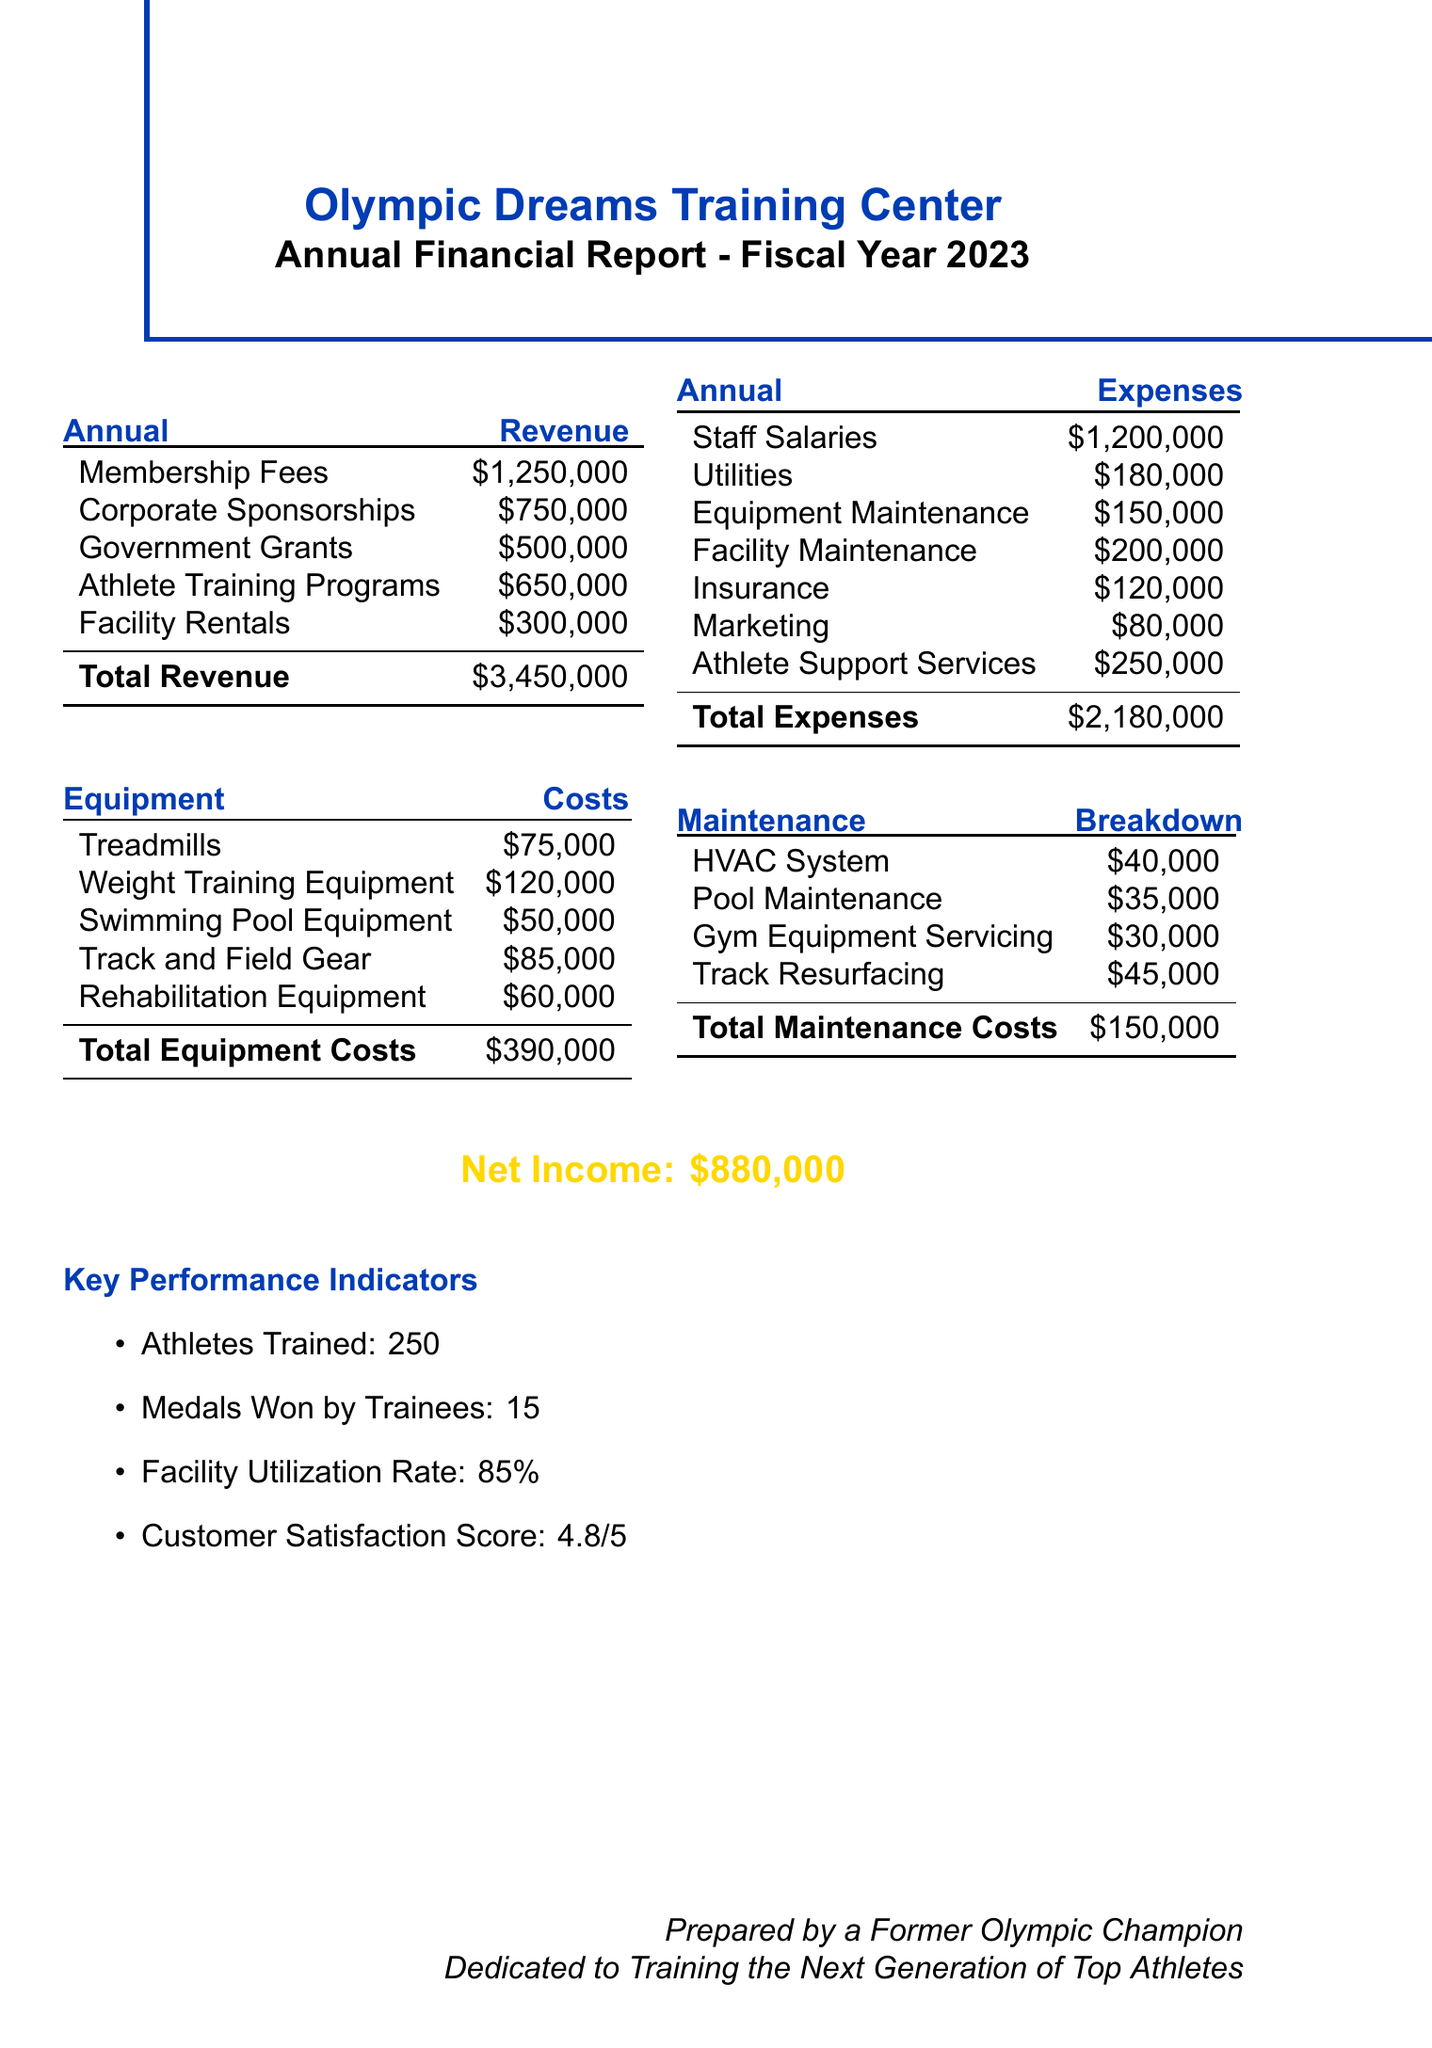what is the total revenue? The total revenue is the sum of all revenue sources in the document: membership fees, corporate sponsorships, government grants, athlete training programs, and facility rentals, which equals $3,450,000.
Answer: $3,450,000 what is the total expenses? The total expenses are the sum of all expenses listed, including staff salaries, utilities, equipment maintenance, facility maintenance, insurance, marketing, and athlete support services, totaling $2,180,000.
Answer: $2,180,000 how much was spent on equipment maintenance? The document specifies the cost of equipment maintenance as a distinct expense, which is $150,000.
Answer: $150,000 what is the net income for the fiscal year 2023? The net income is calculated as the total revenue minus total expenses, which is $3,450,000 - $2,180,000 = $880,000.
Answer: $880,000 how many athletes were trained in 2023? The report indicates that 250 athletes were trained during the fiscal year 2023.
Answer: 250 what was the customer satisfaction score? The document provides a customer satisfaction score of 4.8 out of 5.
Answer: 4.8 out of 5 what are the total equipment costs? The total costs for all equipment listed in the report add up to $390,000.
Answer: $390,000 which category received the highest expense? Staff salaries account for the highest expense listed in the document, totaling $1,200,000.
Answer: Staff salaries what is the facility utilization rate? The facility utilization rate specified in the document is 85%.
Answer: 85% how much was spent on athlete support services? The document shows that $250,000 was allocated for athlete support services.
Answer: $250,000 